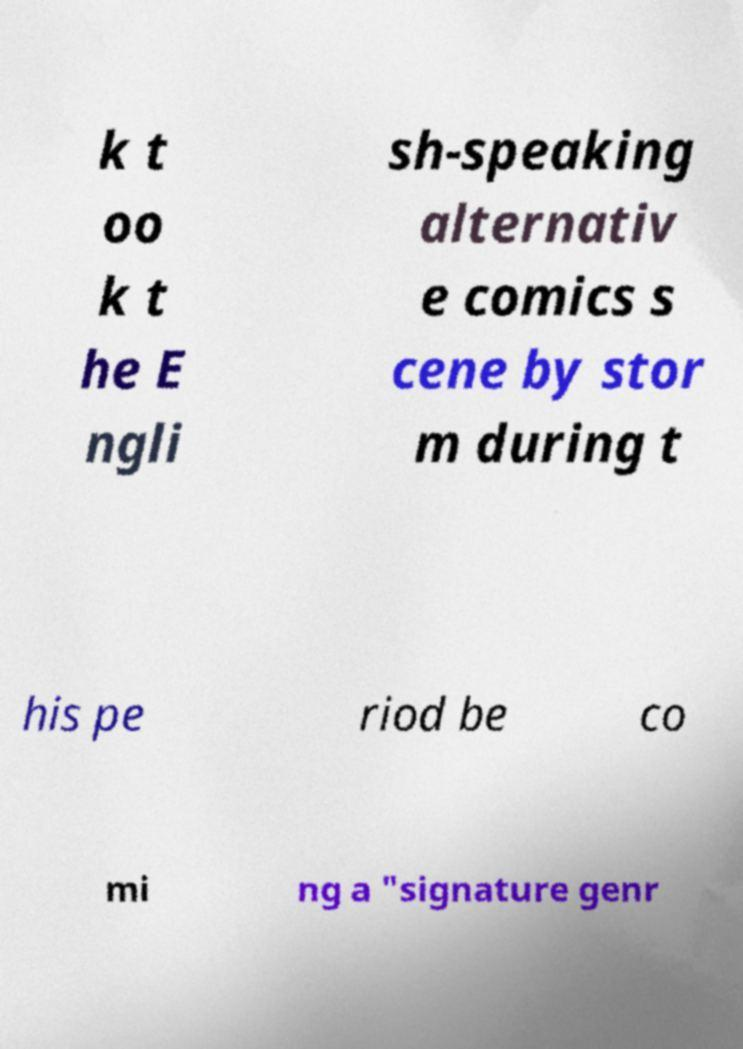Please read and relay the text visible in this image. What does it say? k t oo k t he E ngli sh-speaking alternativ e comics s cene by stor m during t his pe riod be co mi ng a "signature genr 